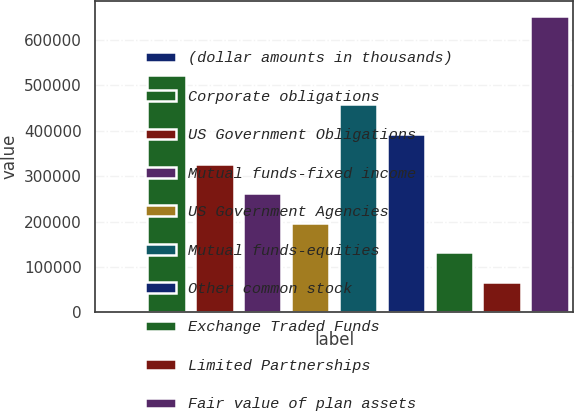Convert chart. <chart><loc_0><loc_0><loc_500><loc_500><bar_chart><fcel>(dollar amounts in thousands)<fcel>Corporate obligations<fcel>US Government Obligations<fcel>Mutual funds-fixed income<fcel>US Government Agencies<fcel>Mutual funds-equities<fcel>Other common stock<fcel>Exchange Traded Funds<fcel>Limited Partnerships<fcel>Fair value of plan assets<nl><fcel>2014<fcel>522813<fcel>327514<fcel>262414<fcel>197314<fcel>457713<fcel>392613<fcel>132214<fcel>67113.9<fcel>653013<nl></chart> 